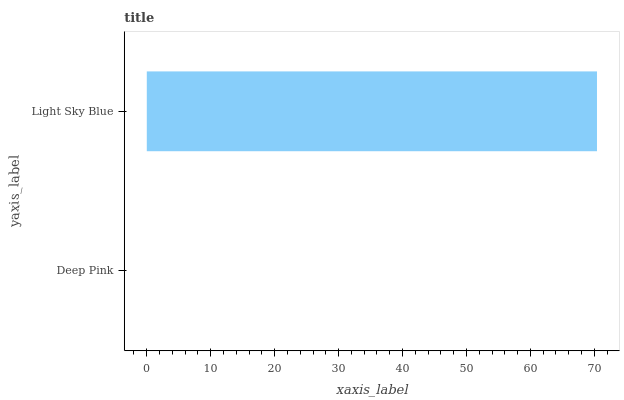Is Deep Pink the minimum?
Answer yes or no. Yes. Is Light Sky Blue the maximum?
Answer yes or no. Yes. Is Light Sky Blue the minimum?
Answer yes or no. No. Is Light Sky Blue greater than Deep Pink?
Answer yes or no. Yes. Is Deep Pink less than Light Sky Blue?
Answer yes or no. Yes. Is Deep Pink greater than Light Sky Blue?
Answer yes or no. No. Is Light Sky Blue less than Deep Pink?
Answer yes or no. No. Is Light Sky Blue the high median?
Answer yes or no. Yes. Is Deep Pink the low median?
Answer yes or no. Yes. Is Deep Pink the high median?
Answer yes or no. No. Is Light Sky Blue the low median?
Answer yes or no. No. 